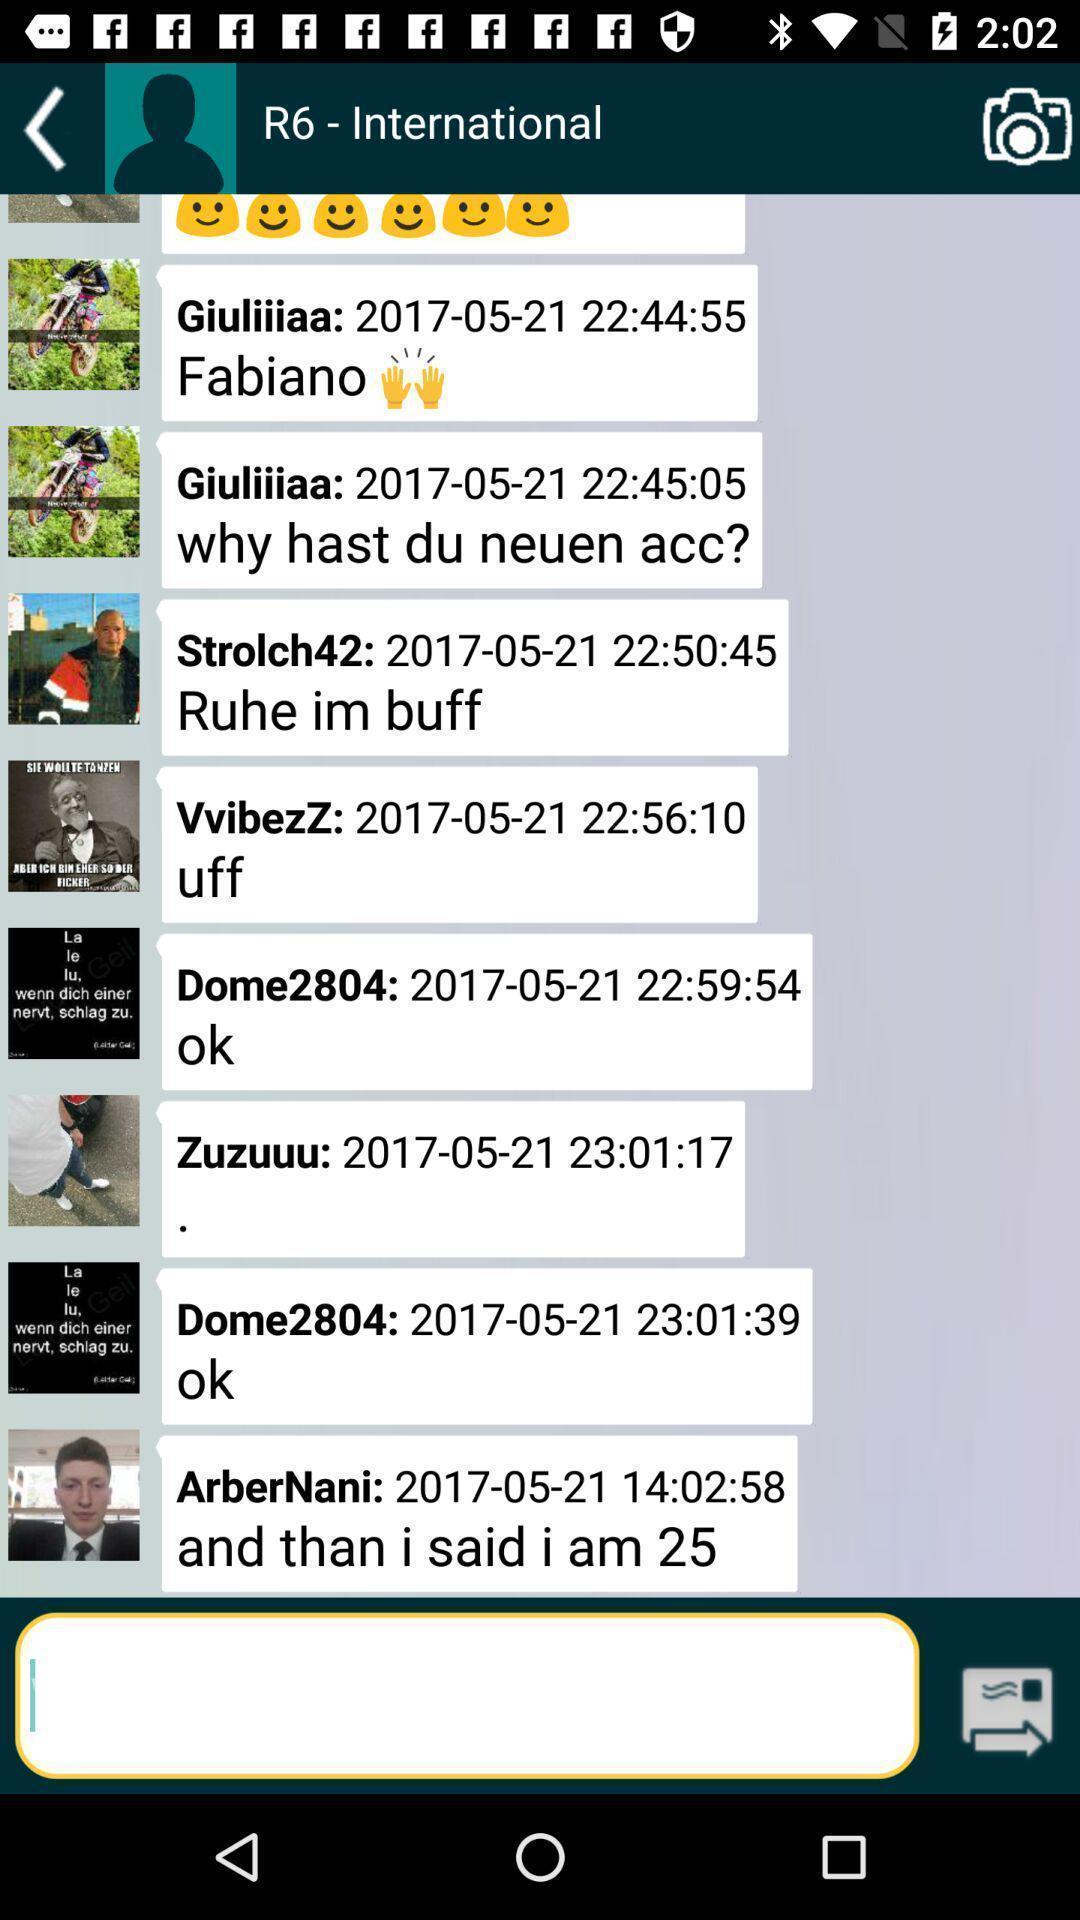What details can you identify in this image? Page displaying the chat in a social app. 